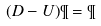Convert formula to latex. <formula><loc_0><loc_0><loc_500><loc_500>( D - U ) \P = \P</formula> 